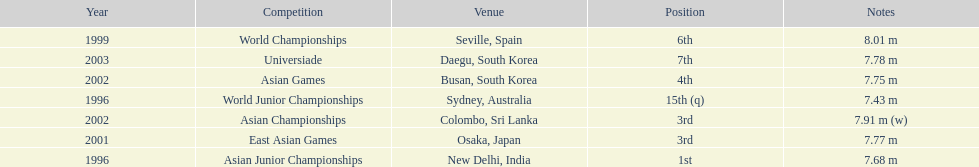Which year was his best jump? 1999. I'm looking to parse the entire table for insights. Could you assist me with that? {'header': ['Year', 'Competition', 'Venue', 'Position', 'Notes'], 'rows': [['1999', 'World Championships', 'Seville, Spain', '6th', '8.01 m'], ['2003', 'Universiade', 'Daegu, South Korea', '7th', '7.78 m'], ['2002', 'Asian Games', 'Busan, South Korea', '4th', '7.75 m'], ['1996', 'World Junior Championships', 'Sydney, Australia', '15th (q)', '7.43 m'], ['2002', 'Asian Championships', 'Colombo, Sri Lanka', '3rd', '7.91 m (w)'], ['2001', 'East Asian Games', 'Osaka, Japan', '3rd', '7.77 m'], ['1996', 'Asian Junior Championships', 'New Delhi, India', '1st', '7.68 m']]} 